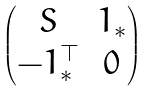Convert formula to latex. <formula><loc_0><loc_0><loc_500><loc_500>\begin{pmatrix} S & 1 _ { * } \\ - 1 _ { * } ^ { \top } & 0 \end{pmatrix}</formula> 